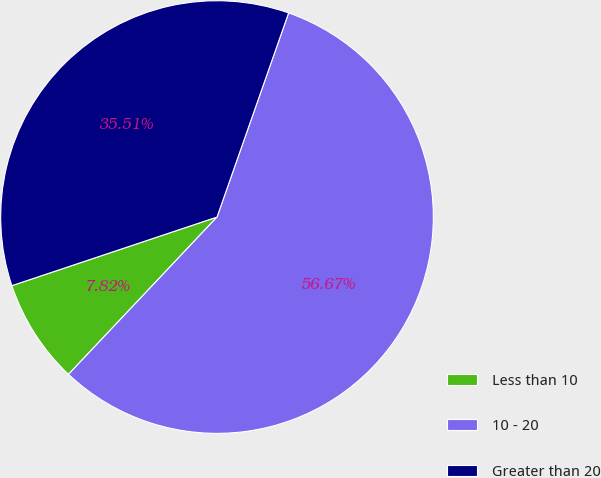Convert chart to OTSL. <chart><loc_0><loc_0><loc_500><loc_500><pie_chart><fcel>Less than 10<fcel>10 - 20<fcel>Greater than 20<nl><fcel>7.82%<fcel>56.68%<fcel>35.51%<nl></chart> 